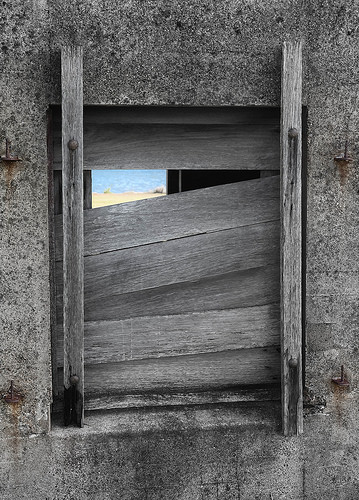<image>
Is the board on the window? Yes. Looking at the image, I can see the board is positioned on top of the window, with the window providing support. 